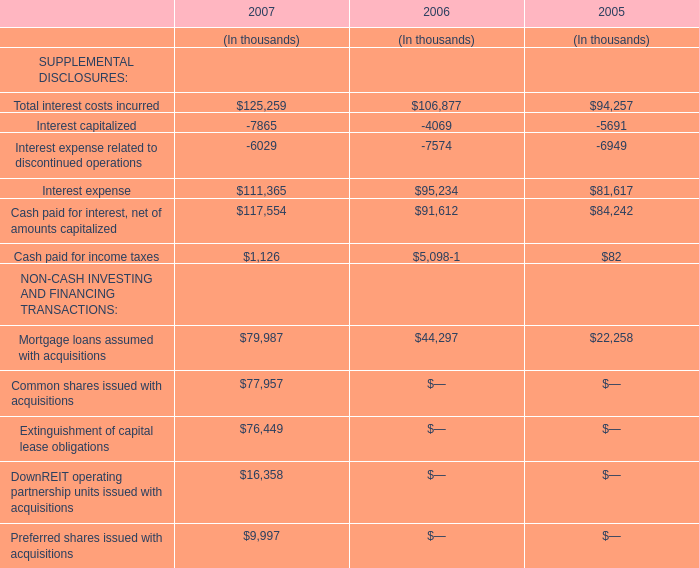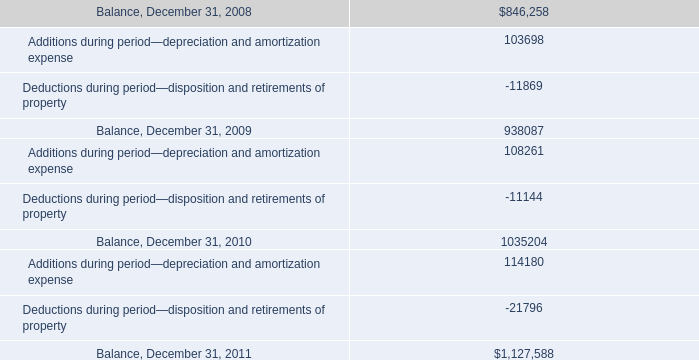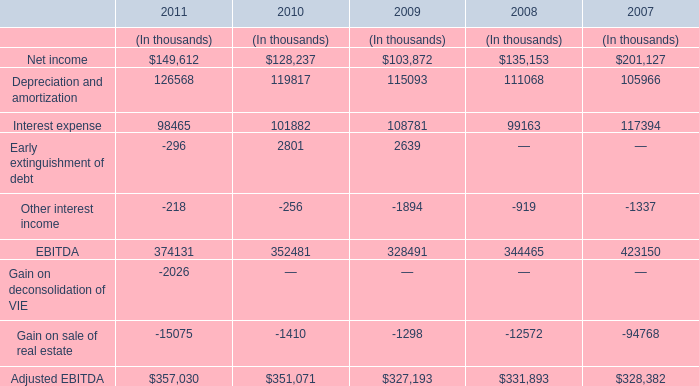What is the sum of the Other interest income in the years where Depreciation and amortization is positive? (in thousand) 
Computations: ((((-218 - 256) - 1894) - 919) - 1337)
Answer: -4624.0. 